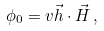<formula> <loc_0><loc_0><loc_500><loc_500>\phi _ { 0 } = v { \vec { h } } \cdot { \vec { H } } \, ,</formula> 